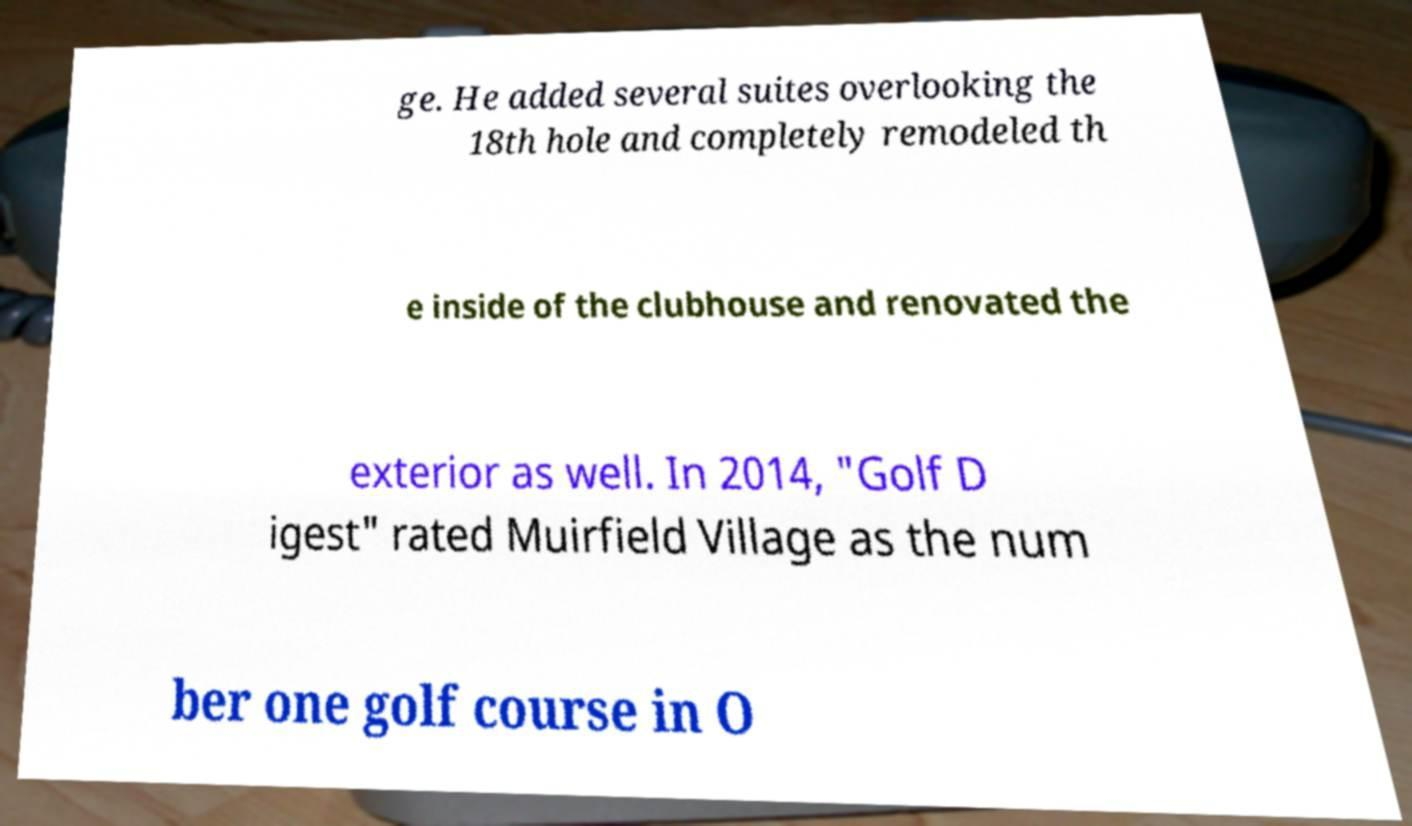What messages or text are displayed in this image? I need them in a readable, typed format. ge. He added several suites overlooking the 18th hole and completely remodeled th e inside of the clubhouse and renovated the exterior as well. In 2014, "Golf D igest" rated Muirfield Village as the num ber one golf course in O 